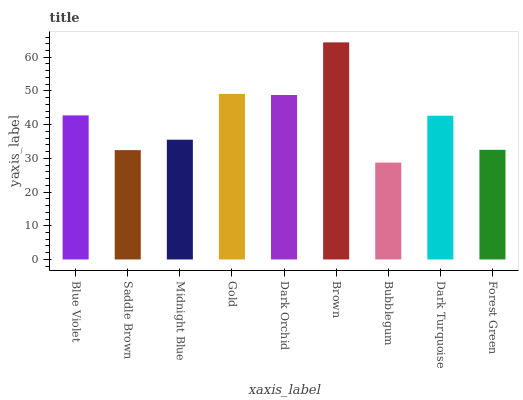Is Bubblegum the minimum?
Answer yes or no. Yes. Is Brown the maximum?
Answer yes or no. Yes. Is Saddle Brown the minimum?
Answer yes or no. No. Is Saddle Brown the maximum?
Answer yes or no. No. Is Blue Violet greater than Saddle Brown?
Answer yes or no. Yes. Is Saddle Brown less than Blue Violet?
Answer yes or no. Yes. Is Saddle Brown greater than Blue Violet?
Answer yes or no. No. Is Blue Violet less than Saddle Brown?
Answer yes or no. No. Is Dark Turquoise the high median?
Answer yes or no. Yes. Is Dark Turquoise the low median?
Answer yes or no. Yes. Is Saddle Brown the high median?
Answer yes or no. No. Is Saddle Brown the low median?
Answer yes or no. No. 